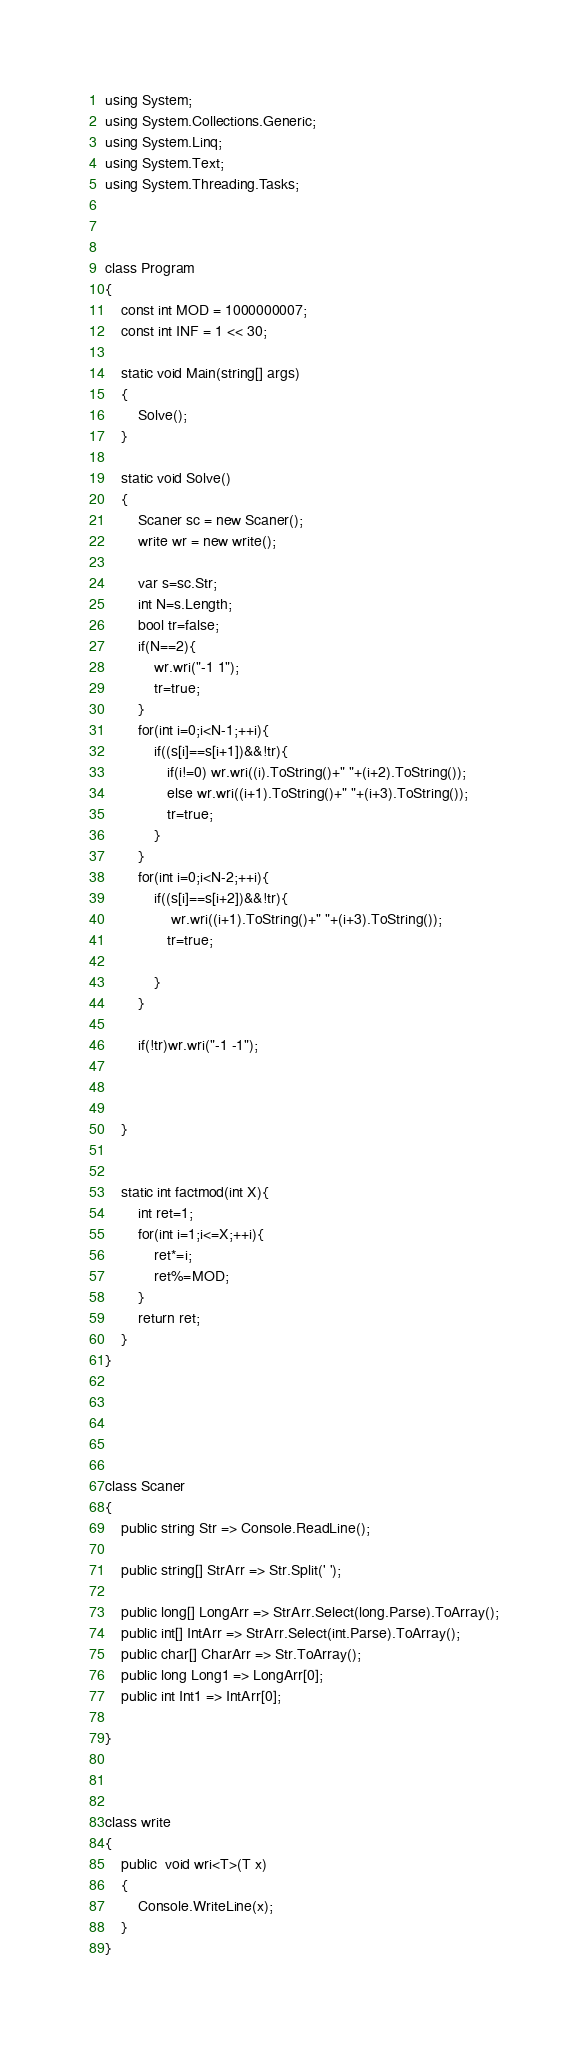Convert code to text. <code><loc_0><loc_0><loc_500><loc_500><_C#_>using System;
using System.Collections.Generic;
using System.Linq;
using System.Text;
using System.Threading.Tasks;



class Program
{
    const int MOD = 1000000007;
    const int INF = 1 << 30;

    static void Main(string[] args)
    {
        Solve();
    }

    static void Solve()
    {
        Scaner sc = new Scaner();
        write wr = new write();

        var s=sc.Str;
        int N=s.Length;
        bool tr=false;
        if(N==2){
            wr.wri("-1 1");
            tr=true;
        }
        for(int i=0;i<N-1;++i){
            if((s[i]==s[i+1])&&!tr){
               if(i!=0) wr.wri((i).ToString()+" "+(i+2).ToString());
               else wr.wri((i+1).ToString()+" "+(i+3).ToString());
               tr=true;
            }
        }
        for(int i=0;i<N-2;++i){
            if((s[i]==s[i+2])&&!tr){
                wr.wri((i+1).ToString()+" "+(i+3).ToString());
               tr=true;

            }
        }
        
        if(!tr)wr.wri("-1 -1");
        

    
    }


    static int factmod(int X){
        int ret=1;
        for(int i=1;i<=X;++i){
            ret*=i;
            ret%=MOD;
        }
        return ret;
    }
}





class Scaner
{
    public string Str => Console.ReadLine();

    public string[] StrArr => Str.Split(' ');

    public long[] LongArr => StrArr.Select(long.Parse).ToArray();
    public int[] IntArr => StrArr.Select(int.Parse).ToArray();
    public char[] CharArr => Str.ToArray();
    public long Long1 => LongArr[0];
    public int Int1 => IntArr[0];
    
}



class write
{
    public  void wri<T>(T x)
    {
        Console.WriteLine(x);
    }
}

</code> 